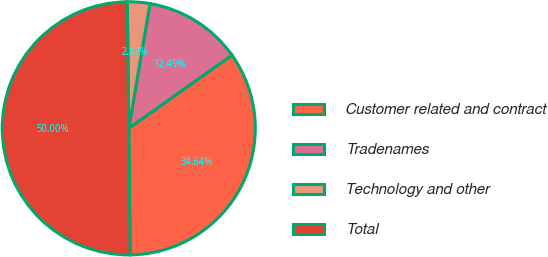<chart> <loc_0><loc_0><loc_500><loc_500><pie_chart><fcel>Customer related and contract<fcel>Tradenames<fcel>Technology and other<fcel>Total<nl><fcel>34.64%<fcel>12.49%<fcel>2.87%<fcel>50.0%<nl></chart> 